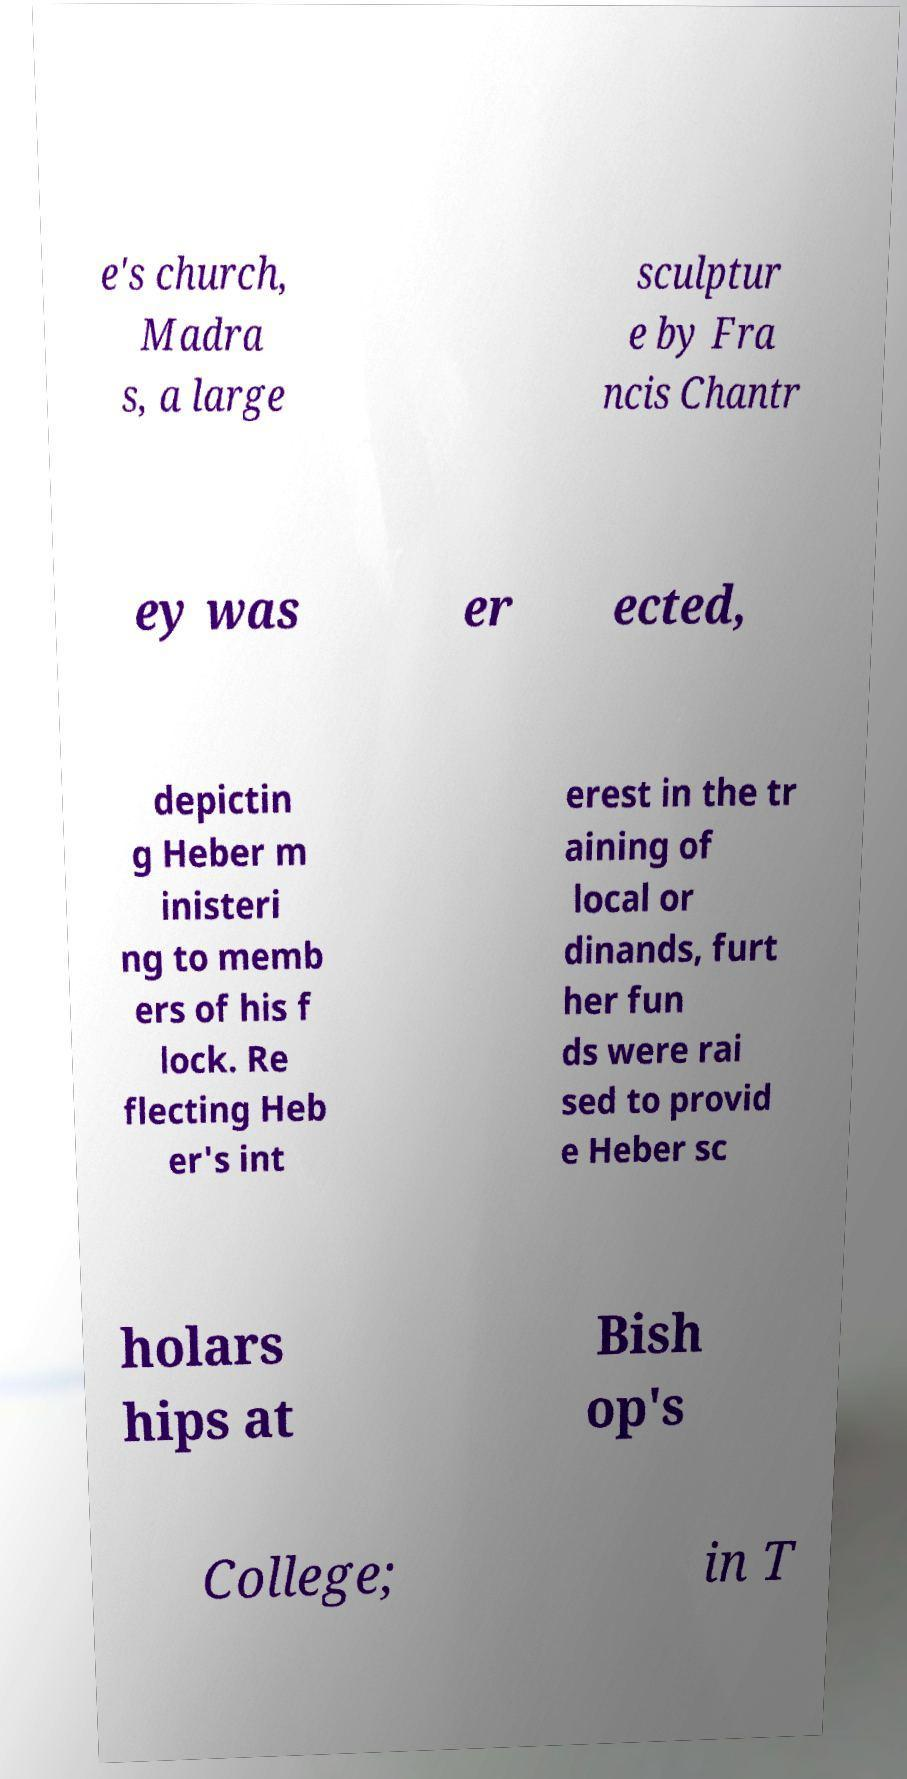Can you read and provide the text displayed in the image?This photo seems to have some interesting text. Can you extract and type it out for me? e's church, Madra s, a large sculptur e by Fra ncis Chantr ey was er ected, depictin g Heber m inisteri ng to memb ers of his f lock. Re flecting Heb er's int erest in the tr aining of local or dinands, furt her fun ds were rai sed to provid e Heber sc holars hips at Bish op's College; in T 